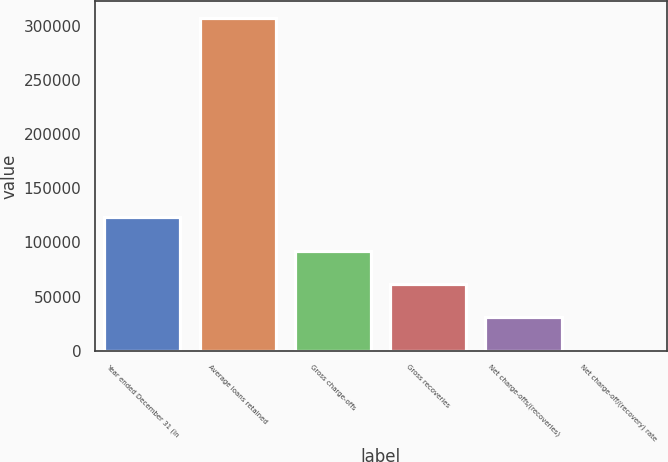Convert chart. <chart><loc_0><loc_0><loc_500><loc_500><bar_chart><fcel>Year ended December 31 (in<fcel>Average loans retained<fcel>Gross charge-offs<fcel>Gross recoveries<fcel>Net charge-offs/(recoveries)<fcel>Net charge-off/(recovery) rate<nl><fcel>122936<fcel>307340<fcel>92202<fcel>61468<fcel>30734<fcel>0.01<nl></chart> 